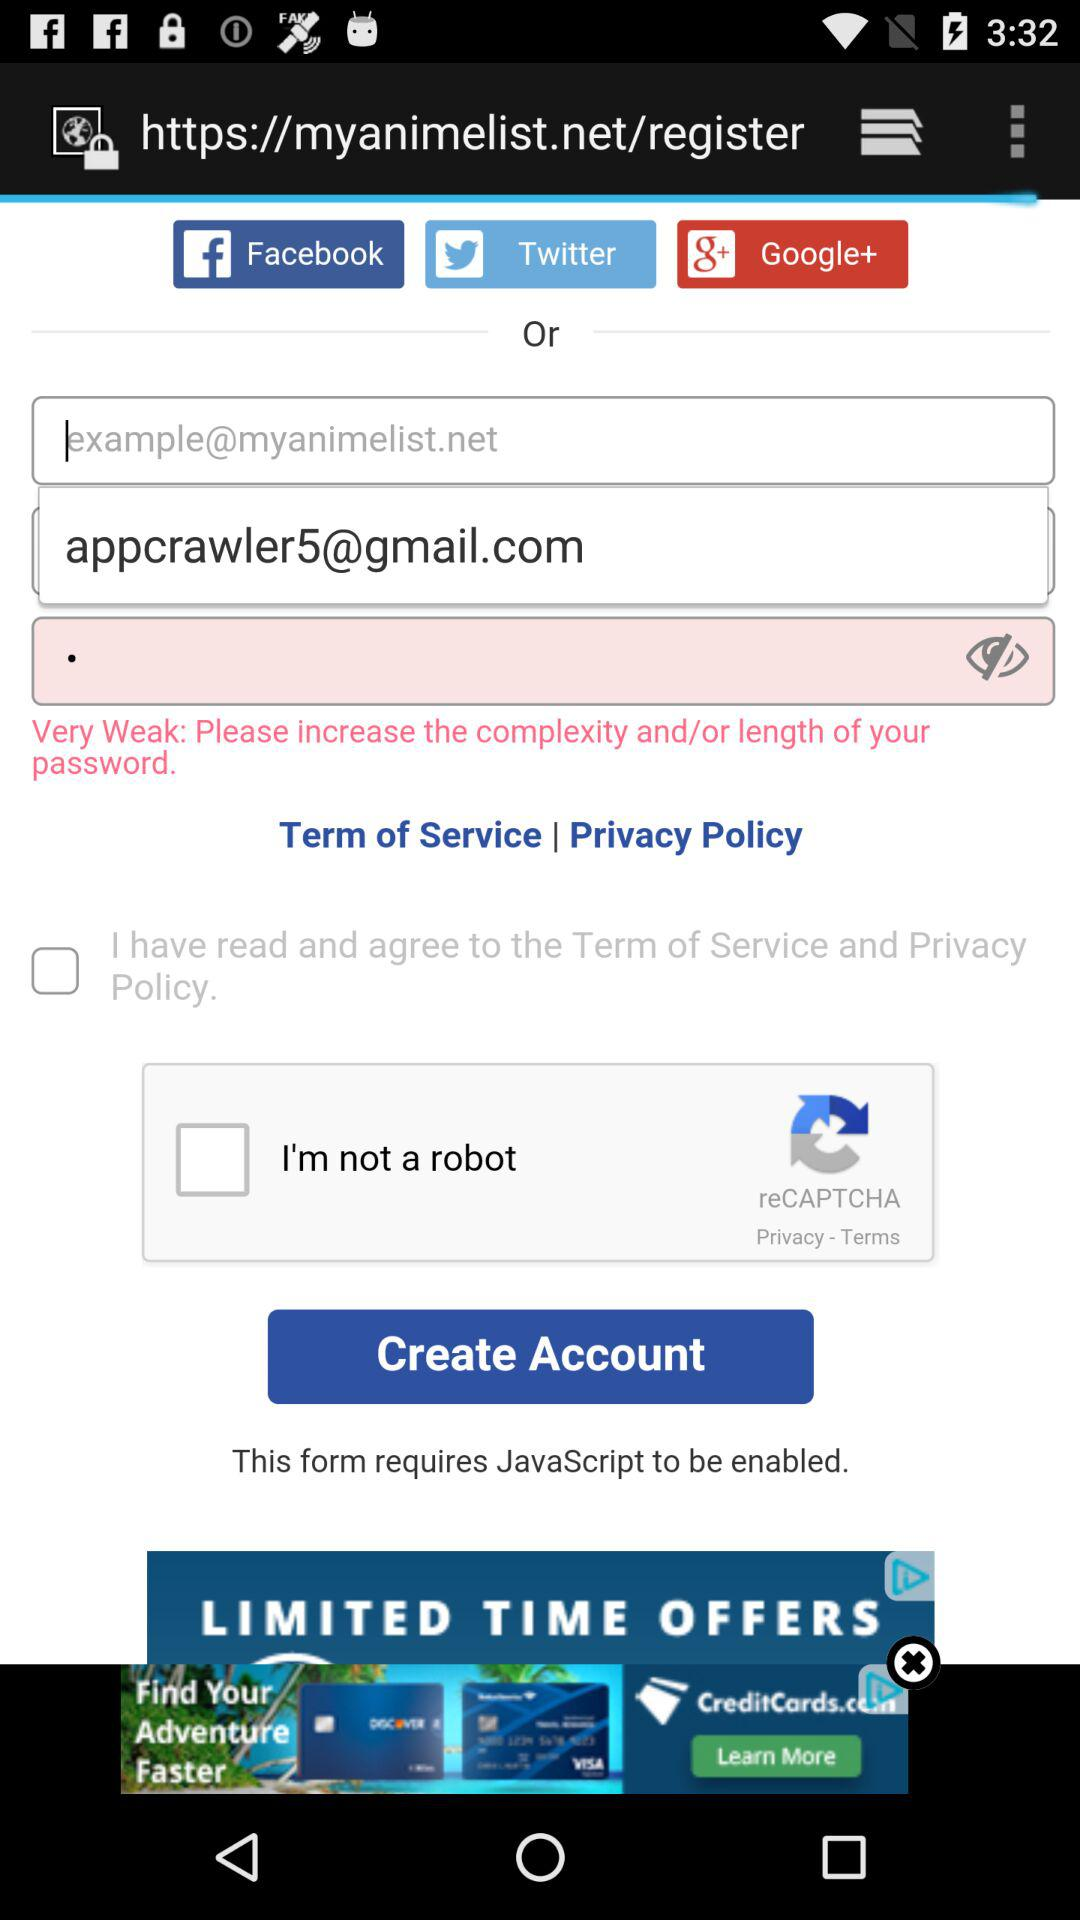What accounts can be used to register? The accounts that can be used are "Facebook", "Twitter" and "Google+". 